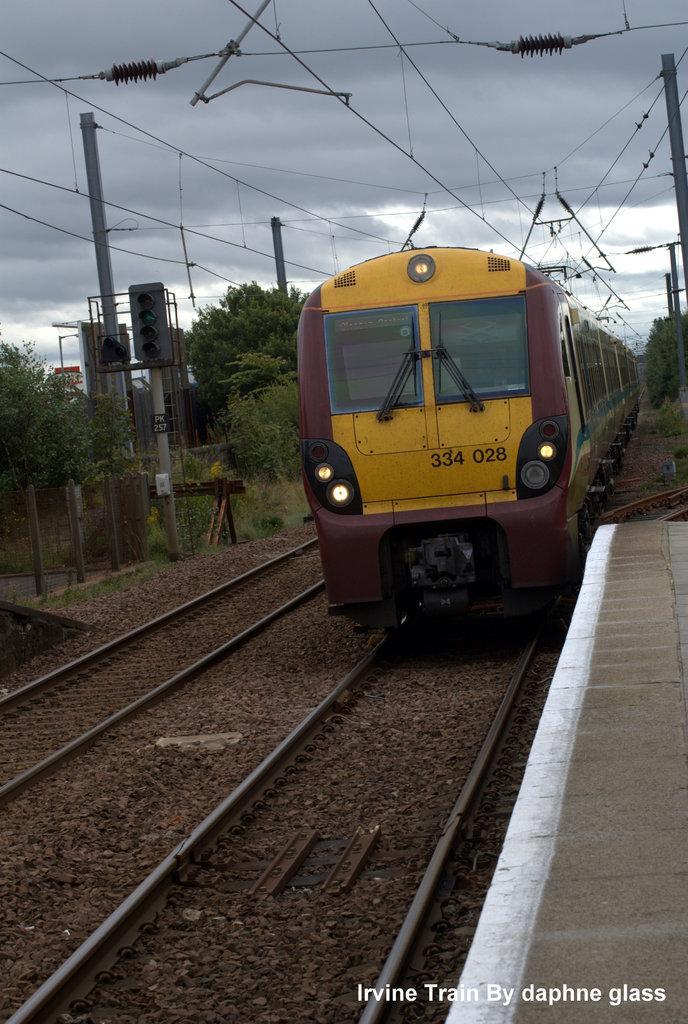How would you summarize this image in a sentence or two? In this image there is a train on the railway track. On the right side of the image there is a platform. In the background of the image there are traffic lights, current poles with cables, trees. At the top of the image there is sky. There is some text at the bottom of the image. 